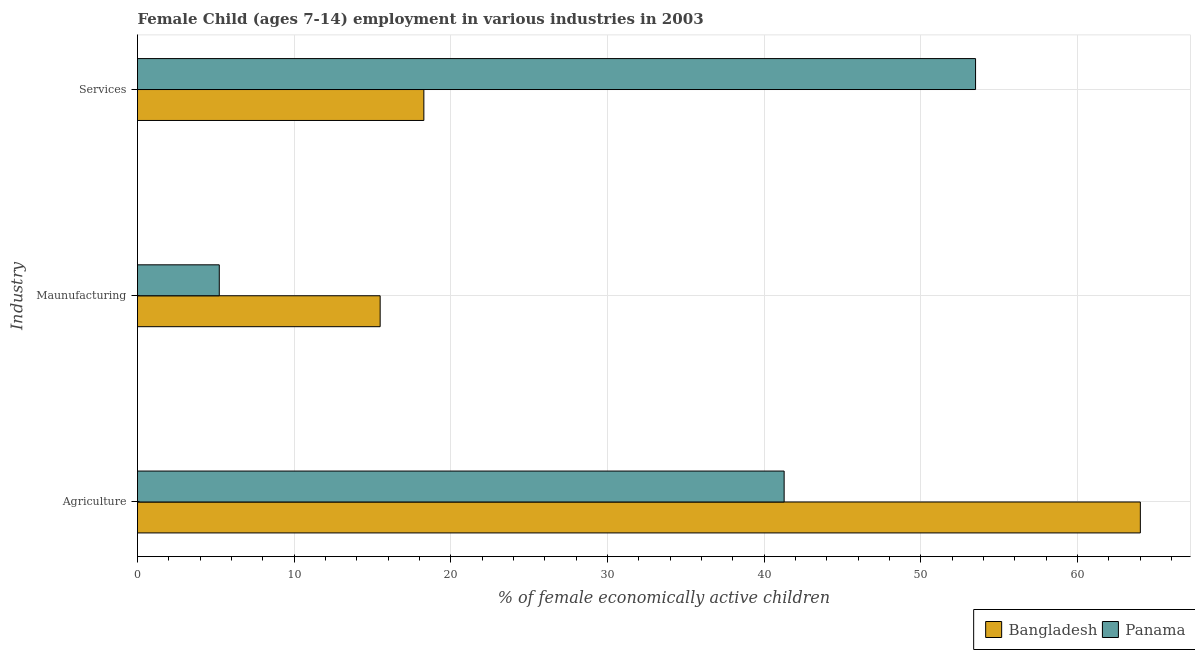How many groups of bars are there?
Provide a short and direct response. 3. How many bars are there on the 3rd tick from the top?
Make the answer very short. 2. What is the label of the 2nd group of bars from the top?
Provide a succinct answer. Maunufacturing. What is the percentage of economically active children in services in Panama?
Your answer should be compact. 53.5. Across all countries, what is the maximum percentage of economically active children in services?
Provide a succinct answer. 53.5. Across all countries, what is the minimum percentage of economically active children in manufacturing?
Make the answer very short. 5.22. In which country was the percentage of economically active children in services maximum?
Your answer should be compact. Panama. In which country was the percentage of economically active children in agriculture minimum?
Keep it short and to the point. Panama. What is the total percentage of economically active children in agriculture in the graph?
Your answer should be compact. 105.3. What is the difference between the percentage of economically active children in manufacturing in Panama and that in Bangladesh?
Offer a very short reply. -10.27. What is the difference between the percentage of economically active children in services in Panama and the percentage of economically active children in manufacturing in Bangladesh?
Ensure brevity in your answer.  38.01. What is the average percentage of economically active children in services per country?
Provide a succinct answer. 35.89. What is the difference between the percentage of economically active children in manufacturing and percentage of economically active children in agriculture in Panama?
Your answer should be very brief. -36.06. In how many countries, is the percentage of economically active children in services greater than 4 %?
Your answer should be compact. 2. What is the ratio of the percentage of economically active children in services in Bangladesh to that in Panama?
Your answer should be very brief. 0.34. Is the percentage of economically active children in services in Bangladesh less than that in Panama?
Provide a succinct answer. Yes. Is the difference between the percentage of economically active children in services in Bangladesh and Panama greater than the difference between the percentage of economically active children in manufacturing in Bangladesh and Panama?
Offer a very short reply. No. What is the difference between the highest and the second highest percentage of economically active children in services?
Provide a short and direct response. 35.22. What is the difference between the highest and the lowest percentage of economically active children in manufacturing?
Your answer should be very brief. 10.27. Is the sum of the percentage of economically active children in agriculture in Bangladesh and Panama greater than the maximum percentage of economically active children in services across all countries?
Ensure brevity in your answer.  Yes. What does the 2nd bar from the top in Maunufacturing represents?
Provide a short and direct response. Bangladesh. Is it the case that in every country, the sum of the percentage of economically active children in agriculture and percentage of economically active children in manufacturing is greater than the percentage of economically active children in services?
Make the answer very short. No. How many bars are there?
Your answer should be very brief. 6. How many countries are there in the graph?
Give a very brief answer. 2. Are the values on the major ticks of X-axis written in scientific E-notation?
Provide a short and direct response. No. Does the graph contain grids?
Give a very brief answer. Yes. Where does the legend appear in the graph?
Your answer should be compact. Bottom right. How many legend labels are there?
Make the answer very short. 2. What is the title of the graph?
Provide a short and direct response. Female Child (ages 7-14) employment in various industries in 2003. What is the label or title of the X-axis?
Provide a short and direct response. % of female economically active children. What is the label or title of the Y-axis?
Make the answer very short. Industry. What is the % of female economically active children of Bangladesh in Agriculture?
Your answer should be very brief. 64.02. What is the % of female economically active children of Panama in Agriculture?
Your answer should be compact. 41.28. What is the % of female economically active children in Bangladesh in Maunufacturing?
Keep it short and to the point. 15.49. What is the % of female economically active children in Panama in Maunufacturing?
Provide a short and direct response. 5.22. What is the % of female economically active children in Bangladesh in Services?
Your response must be concise. 18.28. What is the % of female economically active children of Panama in Services?
Offer a very short reply. 53.5. Across all Industry, what is the maximum % of female economically active children in Bangladesh?
Your response must be concise. 64.02. Across all Industry, what is the maximum % of female economically active children in Panama?
Offer a very short reply. 53.5. Across all Industry, what is the minimum % of female economically active children of Bangladesh?
Your answer should be very brief. 15.49. Across all Industry, what is the minimum % of female economically active children of Panama?
Offer a terse response. 5.22. What is the total % of female economically active children in Bangladesh in the graph?
Your answer should be compact. 97.79. What is the total % of female economically active children of Panama in the graph?
Ensure brevity in your answer.  100. What is the difference between the % of female economically active children in Bangladesh in Agriculture and that in Maunufacturing?
Offer a very short reply. 48.53. What is the difference between the % of female economically active children of Panama in Agriculture and that in Maunufacturing?
Provide a succinct answer. 36.06. What is the difference between the % of female economically active children in Bangladesh in Agriculture and that in Services?
Ensure brevity in your answer.  45.74. What is the difference between the % of female economically active children of Panama in Agriculture and that in Services?
Make the answer very short. -12.22. What is the difference between the % of female economically active children of Bangladesh in Maunufacturing and that in Services?
Offer a terse response. -2.79. What is the difference between the % of female economically active children of Panama in Maunufacturing and that in Services?
Keep it short and to the point. -48.28. What is the difference between the % of female economically active children of Bangladesh in Agriculture and the % of female economically active children of Panama in Maunufacturing?
Ensure brevity in your answer.  58.8. What is the difference between the % of female economically active children of Bangladesh in Agriculture and the % of female economically active children of Panama in Services?
Keep it short and to the point. 10.52. What is the difference between the % of female economically active children in Bangladesh in Maunufacturing and the % of female economically active children in Panama in Services?
Keep it short and to the point. -38.01. What is the average % of female economically active children in Bangladesh per Industry?
Your answer should be compact. 32.6. What is the average % of female economically active children in Panama per Industry?
Make the answer very short. 33.33. What is the difference between the % of female economically active children of Bangladesh and % of female economically active children of Panama in Agriculture?
Offer a very short reply. 22.74. What is the difference between the % of female economically active children in Bangladesh and % of female economically active children in Panama in Maunufacturing?
Your response must be concise. 10.27. What is the difference between the % of female economically active children in Bangladesh and % of female economically active children in Panama in Services?
Your answer should be very brief. -35.22. What is the ratio of the % of female economically active children in Bangladesh in Agriculture to that in Maunufacturing?
Provide a short and direct response. 4.13. What is the ratio of the % of female economically active children of Panama in Agriculture to that in Maunufacturing?
Give a very brief answer. 7.91. What is the ratio of the % of female economically active children of Bangladesh in Agriculture to that in Services?
Provide a short and direct response. 3.5. What is the ratio of the % of female economically active children in Panama in Agriculture to that in Services?
Offer a terse response. 0.77. What is the ratio of the % of female economically active children in Bangladesh in Maunufacturing to that in Services?
Ensure brevity in your answer.  0.85. What is the ratio of the % of female economically active children in Panama in Maunufacturing to that in Services?
Keep it short and to the point. 0.1. What is the difference between the highest and the second highest % of female economically active children of Bangladesh?
Your response must be concise. 45.74. What is the difference between the highest and the second highest % of female economically active children in Panama?
Keep it short and to the point. 12.22. What is the difference between the highest and the lowest % of female economically active children of Bangladesh?
Give a very brief answer. 48.53. What is the difference between the highest and the lowest % of female economically active children in Panama?
Offer a very short reply. 48.28. 